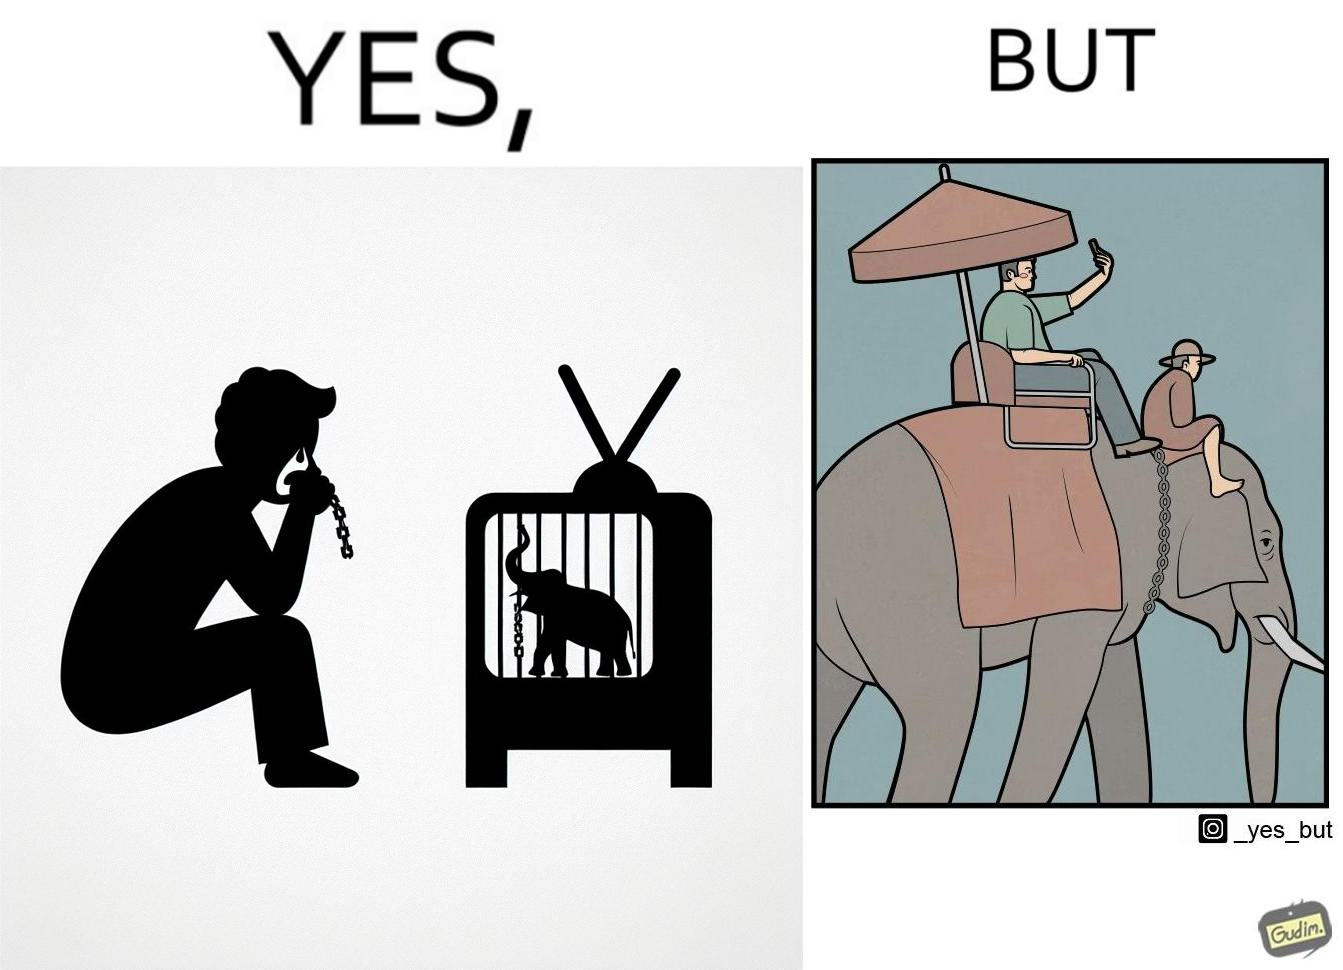Explain the humor or irony in this image. The image is ironic, because the people who get sentimental over imprisoned animal while watching TV shows often feel okay when using animals for labor 